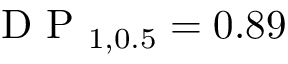<formula> <loc_0><loc_0><loc_500><loc_500>D P _ { 1 , 0 . 5 } = 0 . 8 9</formula> 